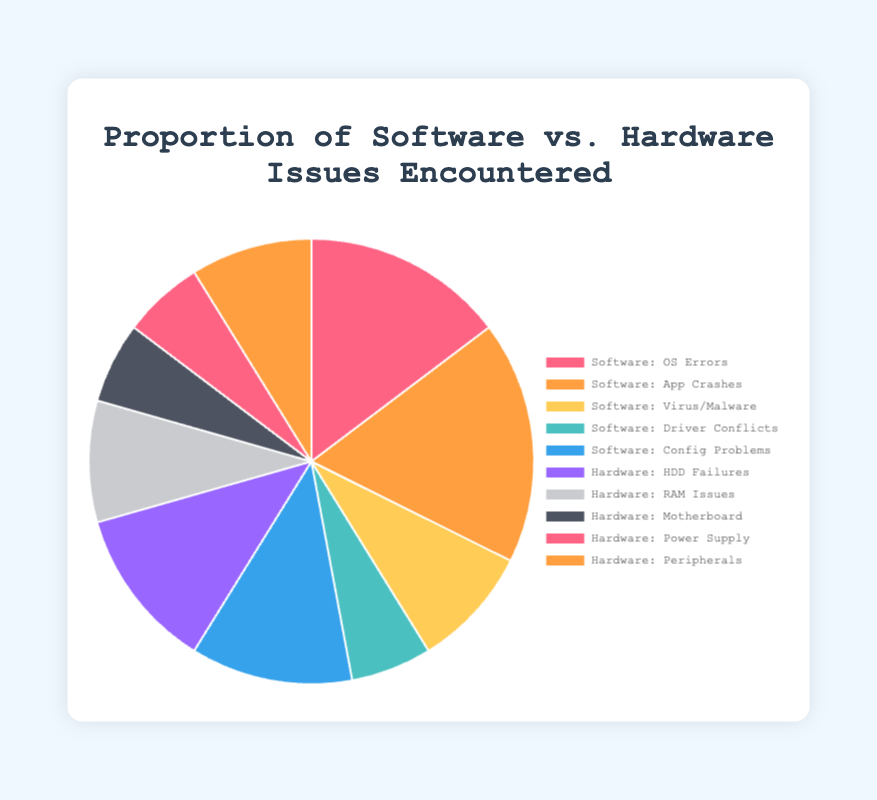What proportion of total issues are Software Issues? Sum the data points of Software Issues to get 100. The total of all issues (Software + Hardware) is 170. The proportion is (100/170) * 100%.
Answer: 58.8% What's the most common issue type encountered? Review the data points to see which has the highest value. Application Crashes under Software Issues has the highest at 30.
Answer: Application Crashes What is the least reported type of issue? Review the data points to see which has the lowest value. Driver Conflicts and Motherboard Problems both have the lowest at 10 each.
Answer: Driver Conflicts, Motherboard Problems How do Software Issues compare to Hardware Issues in terms of their contribution to total issues? Sum the data points for Software Issues (100) and Hardware Issues (70). Compare the two totals.
Answer: Software Issues are greater than Hardware Issues Which Software Issue category has the smallest proportion and what is it? Review the Software Issues data points and find the smallest value, which is Driver Conflicts at 10.
Answer: Driver Conflicts, 10 Compare the number of Hard Drive Failures to Configuration Problems. Which one is greater and by how much? Compare the values of Hard Drive Failures (20) to Configuration Problems (20).
Answer: They are equal What percentage of the issues are stemming from Hard Drive Failures? Hard Drive Failures are 20 out of the total 170 issues. Calculate (20/170) * 100%.
Answer: 11.8% What color represents Operating System Errors in the pie chart? From the color sequences provided, the first color corresponds to the first label. Therefore, Operating System Errors are represented by '#FF6384' (pink).
Answer: Pink What are the cumulative Software Issues excluding Virus/Malware Attacks? Sum the data points of Software Issues excluding Virus/Malware Attacks (25 + 30 + 10 + 20 = 85).
Answer: 85 Which category of issue has more instances: Peripheral Malfunctions or RAM Issues? Compare Peripheral Malfunctions (15) with RAM Issues (15).
Answer: They are equal 